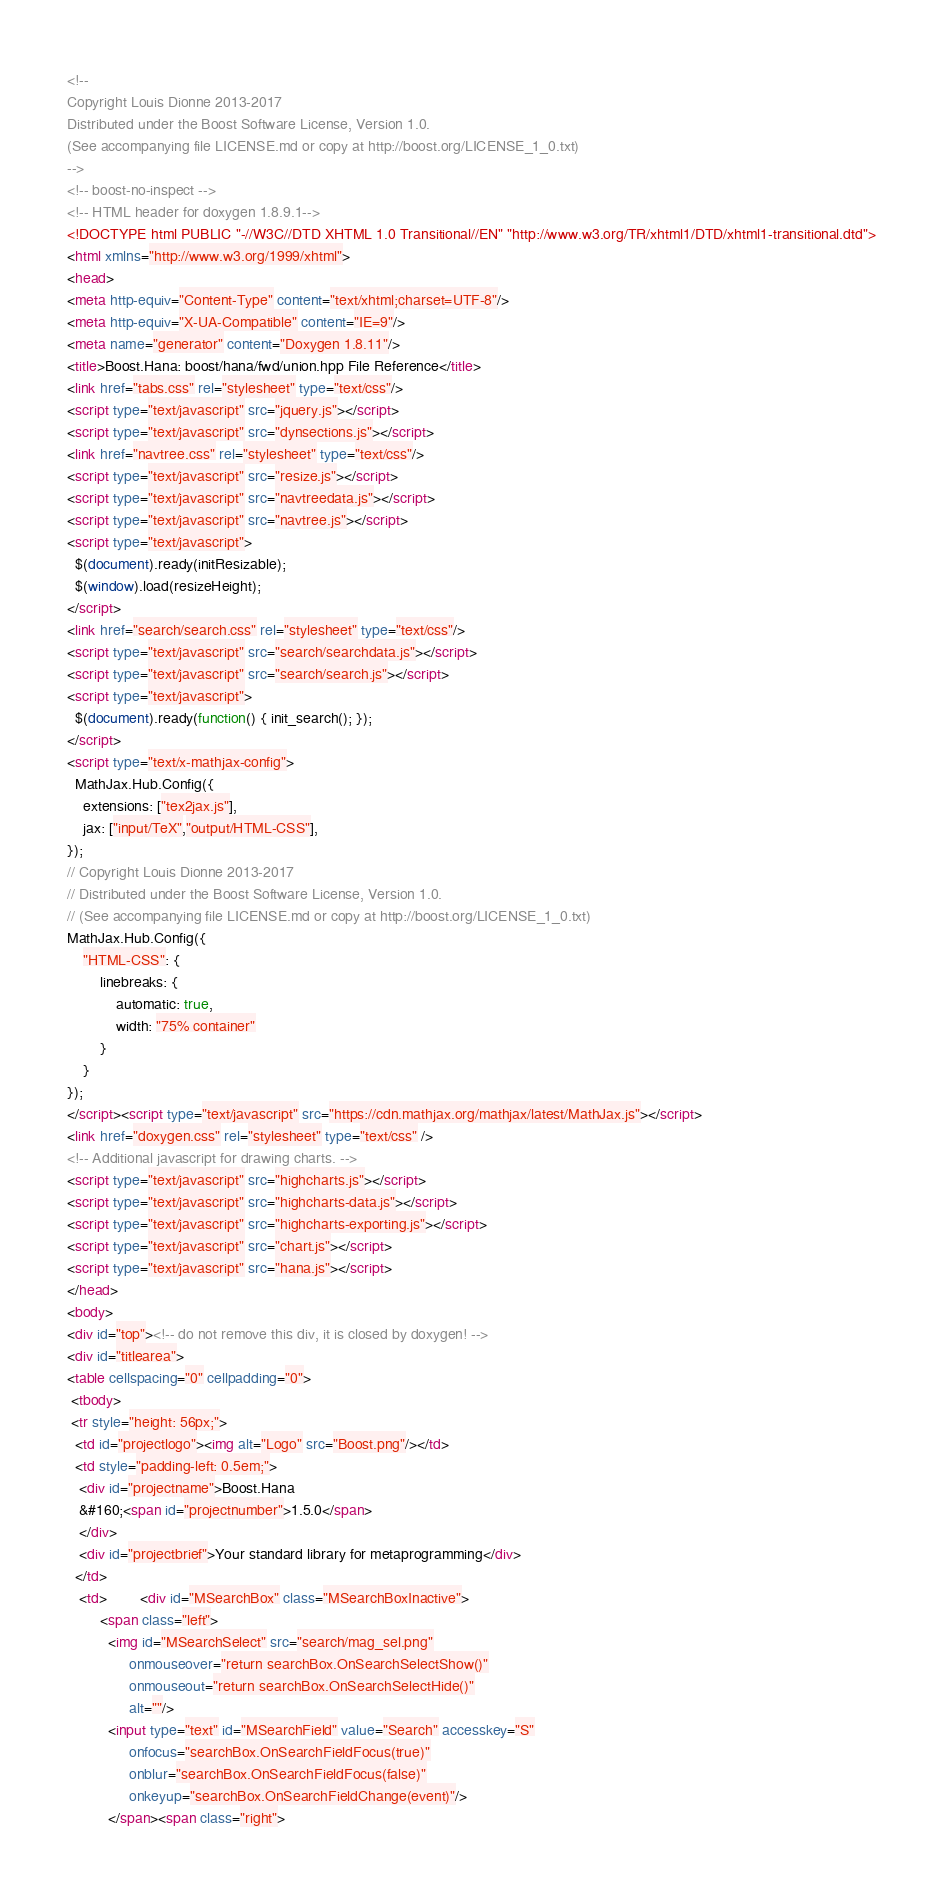<code> <loc_0><loc_0><loc_500><loc_500><_HTML_><!--
Copyright Louis Dionne 2013-2017
Distributed under the Boost Software License, Version 1.0.
(See accompanying file LICENSE.md or copy at http://boost.org/LICENSE_1_0.txt)
-->
<!-- boost-no-inspect -->
<!-- HTML header for doxygen 1.8.9.1-->
<!DOCTYPE html PUBLIC "-//W3C//DTD XHTML 1.0 Transitional//EN" "http://www.w3.org/TR/xhtml1/DTD/xhtml1-transitional.dtd">
<html xmlns="http://www.w3.org/1999/xhtml">
<head>
<meta http-equiv="Content-Type" content="text/xhtml;charset=UTF-8"/>
<meta http-equiv="X-UA-Compatible" content="IE=9"/>
<meta name="generator" content="Doxygen 1.8.11"/>
<title>Boost.Hana: boost/hana/fwd/union.hpp File Reference</title>
<link href="tabs.css" rel="stylesheet" type="text/css"/>
<script type="text/javascript" src="jquery.js"></script>
<script type="text/javascript" src="dynsections.js"></script>
<link href="navtree.css" rel="stylesheet" type="text/css"/>
<script type="text/javascript" src="resize.js"></script>
<script type="text/javascript" src="navtreedata.js"></script>
<script type="text/javascript" src="navtree.js"></script>
<script type="text/javascript">
  $(document).ready(initResizable);
  $(window).load(resizeHeight);
</script>
<link href="search/search.css" rel="stylesheet" type="text/css"/>
<script type="text/javascript" src="search/searchdata.js"></script>
<script type="text/javascript" src="search/search.js"></script>
<script type="text/javascript">
  $(document).ready(function() { init_search(); });
</script>
<script type="text/x-mathjax-config">
  MathJax.Hub.Config({
    extensions: ["tex2jax.js"],
    jax: ["input/TeX","output/HTML-CSS"],
});
// Copyright Louis Dionne 2013-2017
// Distributed under the Boost Software License, Version 1.0.
// (See accompanying file LICENSE.md or copy at http://boost.org/LICENSE_1_0.txt)
MathJax.Hub.Config({
    "HTML-CSS": {
        linebreaks: {
            automatic: true,
            width: "75% container"
        }
    }
});
</script><script type="text/javascript" src="https://cdn.mathjax.org/mathjax/latest/MathJax.js"></script>
<link href="doxygen.css" rel="stylesheet" type="text/css" />
<!-- Additional javascript for drawing charts. -->
<script type="text/javascript" src="highcharts.js"></script>
<script type="text/javascript" src="highcharts-data.js"></script>
<script type="text/javascript" src="highcharts-exporting.js"></script>
<script type="text/javascript" src="chart.js"></script>
<script type="text/javascript" src="hana.js"></script>
</head>
<body>
<div id="top"><!-- do not remove this div, it is closed by doxygen! -->
<div id="titlearea">
<table cellspacing="0" cellpadding="0">
 <tbody>
 <tr style="height: 56px;">
  <td id="projectlogo"><img alt="Logo" src="Boost.png"/></td>
  <td style="padding-left: 0.5em;">
   <div id="projectname">Boost.Hana
   &#160;<span id="projectnumber">1.5.0</span>
   </div>
   <div id="projectbrief">Your standard library for metaprogramming</div>
  </td>
   <td>        <div id="MSearchBox" class="MSearchBoxInactive">
        <span class="left">
          <img id="MSearchSelect" src="search/mag_sel.png"
               onmouseover="return searchBox.OnSearchSelectShow()"
               onmouseout="return searchBox.OnSearchSelectHide()"
               alt=""/>
          <input type="text" id="MSearchField" value="Search" accesskey="S"
               onfocus="searchBox.OnSearchFieldFocus(true)" 
               onblur="searchBox.OnSearchFieldFocus(false)" 
               onkeyup="searchBox.OnSearchFieldChange(event)"/>
          </span><span class="right"></code> 